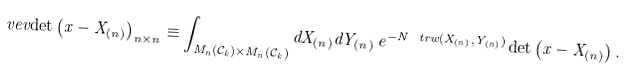<formula> <loc_0><loc_0><loc_500><loc_500>\ v e v { \det \left ( x - X _ { ( n ) } \right ) } _ { n \times n } \equiv \int _ { M _ { n } ( \mathcal { C } _ { k } ) \times M _ { n } ( \mathcal { C } _ { k } ) } d X _ { ( n ) } d Y _ { ( n ) } \, e ^ { - N \ t r w ( X _ { ( n ) } , Y _ { ( n ) } ) } \det \left ( x - X _ { ( n ) } \right ) .</formula> 